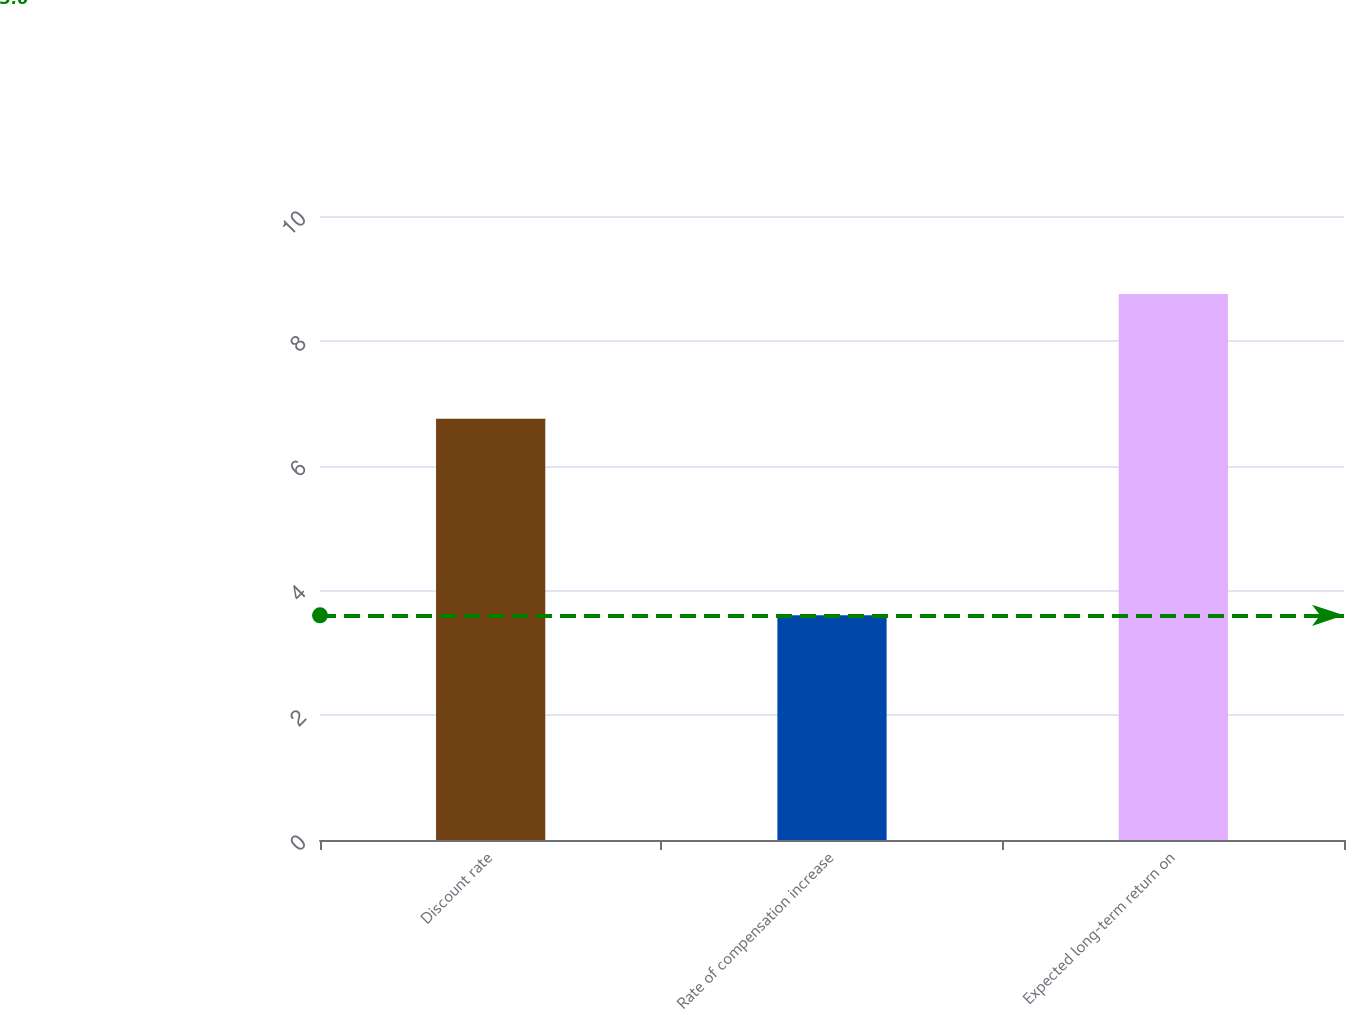Convert chart to OTSL. <chart><loc_0><loc_0><loc_500><loc_500><bar_chart><fcel>Discount rate<fcel>Rate of compensation increase<fcel>Expected long-term return on<nl><fcel>6.75<fcel>3.6<fcel>8.75<nl></chart> 